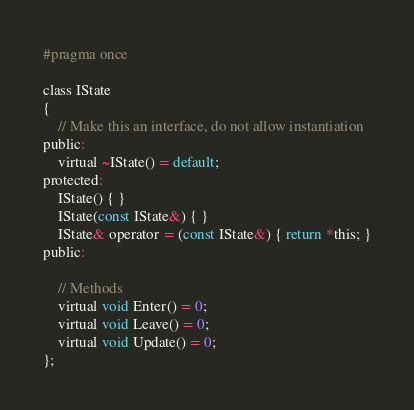<code> <loc_0><loc_0><loc_500><loc_500><_C_>#pragma once

class IState
{
	// Make this an interface, do not allow instantiation
public:
	virtual ~IState() = default;
protected:
	IState() { }
	IState(const IState&) { }
	IState& operator = (const IState&) { return *this; }
public:

	// Methods
	virtual void Enter() = 0;
	virtual void Leave() = 0;
	virtual void Update() = 0;
};
</code> 